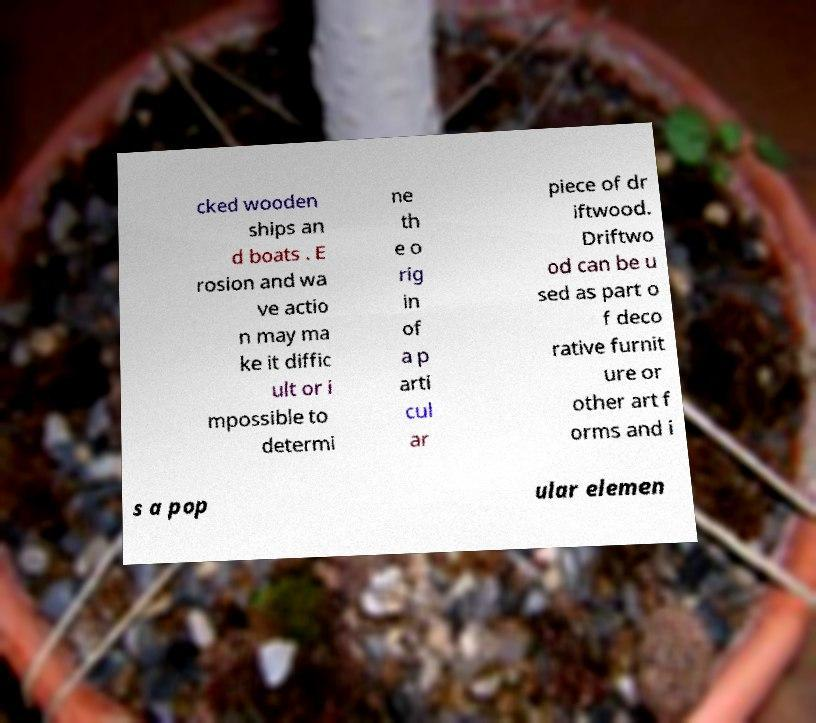Please read and relay the text visible in this image. What does it say? cked wooden ships an d boats . E rosion and wa ve actio n may ma ke it diffic ult or i mpossible to determi ne th e o rig in of a p arti cul ar piece of dr iftwood. Driftwo od can be u sed as part o f deco rative furnit ure or other art f orms and i s a pop ular elemen 